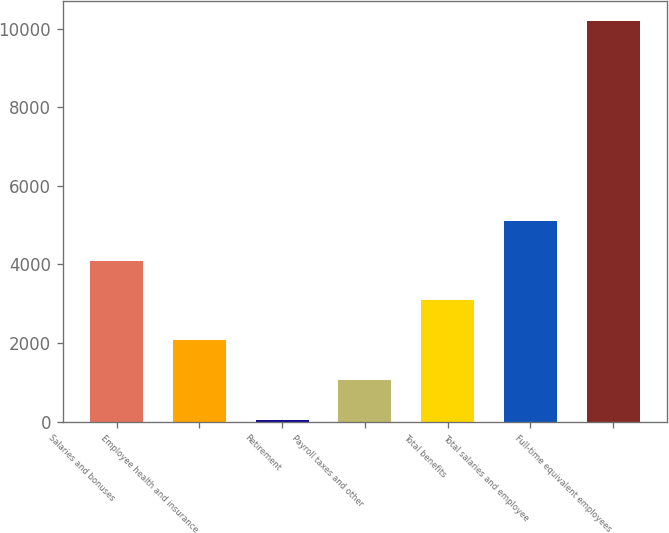Convert chart to OTSL. <chart><loc_0><loc_0><loc_500><loc_500><bar_chart><fcel>Salaries and bonuses<fcel>Employee health and insurance<fcel>Retirement<fcel>Payroll taxes and other<fcel>Total benefits<fcel>Total salaries and employee<fcel>Full-time equivalent employees<nl><fcel>4100.04<fcel>2066.72<fcel>33.4<fcel>1050.06<fcel>3083.38<fcel>5116.7<fcel>10200<nl></chart> 